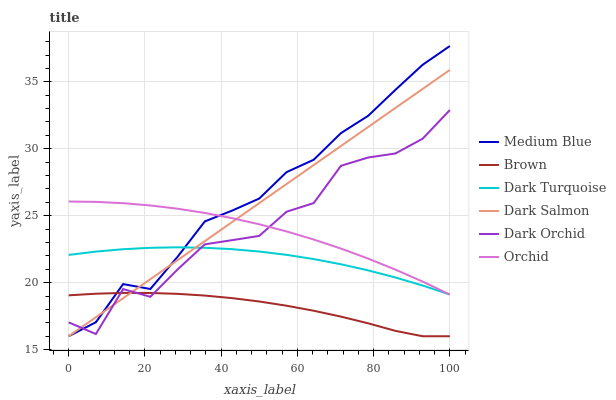Does Brown have the minimum area under the curve?
Answer yes or no. Yes. Does Medium Blue have the maximum area under the curve?
Answer yes or no. Yes. Does Dark Turquoise have the minimum area under the curve?
Answer yes or no. No. Does Dark Turquoise have the maximum area under the curve?
Answer yes or no. No. Is Dark Salmon the smoothest?
Answer yes or no. Yes. Is Dark Orchid the roughest?
Answer yes or no. Yes. Is Dark Turquoise the smoothest?
Answer yes or no. No. Is Dark Turquoise the roughest?
Answer yes or no. No. Does Brown have the lowest value?
Answer yes or no. Yes. Does Dark Turquoise have the lowest value?
Answer yes or no. No. Does Medium Blue have the highest value?
Answer yes or no. Yes. Does Dark Turquoise have the highest value?
Answer yes or no. No. Is Brown less than Dark Turquoise?
Answer yes or no. Yes. Is Orchid greater than Brown?
Answer yes or no. Yes. Does Dark Salmon intersect Medium Blue?
Answer yes or no. Yes. Is Dark Salmon less than Medium Blue?
Answer yes or no. No. Is Dark Salmon greater than Medium Blue?
Answer yes or no. No. Does Brown intersect Dark Turquoise?
Answer yes or no. No. 